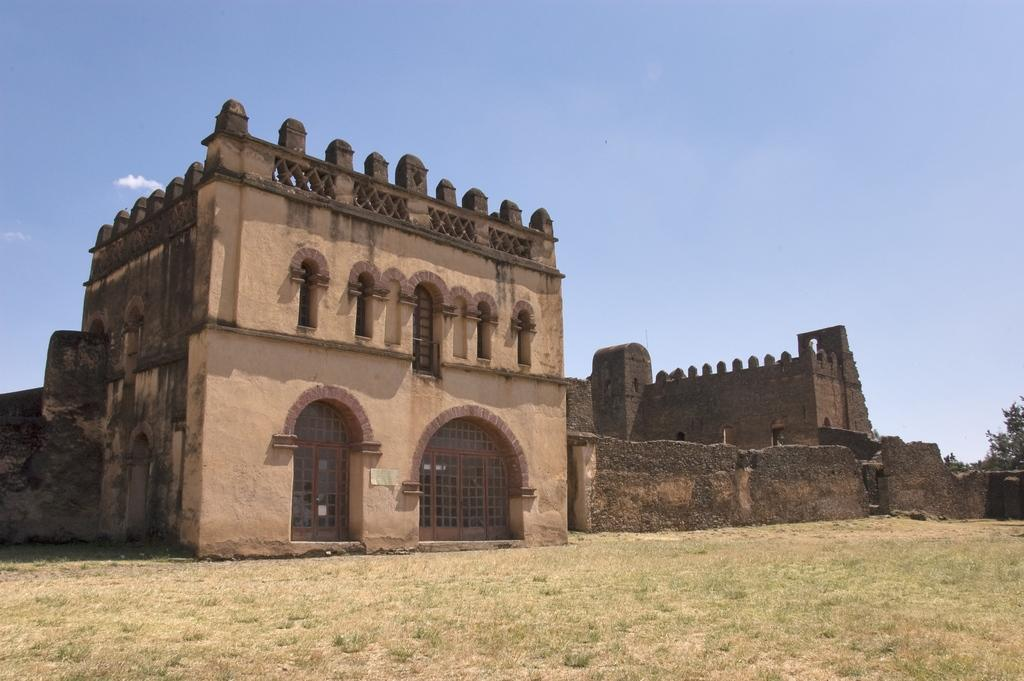What is the main subject in the center of the image? There are forts in the center of the image. What can be seen in the background of the image? There are trees in the background of the image. What is visible at the bottom of the image? The ground is visible at the bottom of the image. What is visible at the top of the image? The sky is visible at the top of the image. How does the wilderness express regret in the image? There is no wilderness present in the image, and therefore no expression of regret can be observed. 